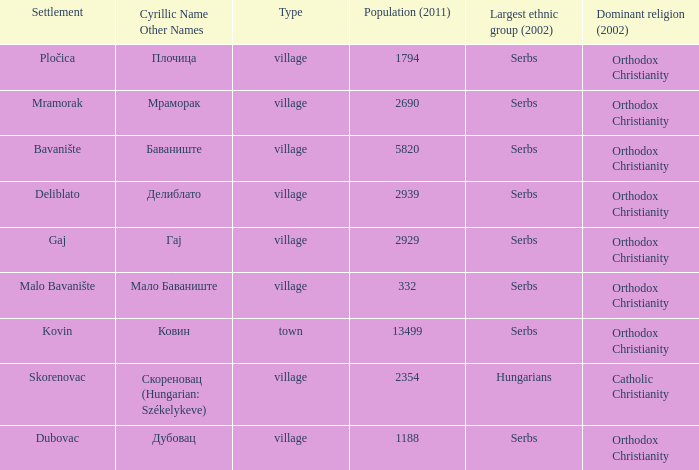What is the Deliblato village known as in Cyrillic? Делиблато. 